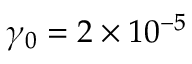Convert formula to latex. <formula><loc_0><loc_0><loc_500><loc_500>\gamma _ { 0 } = 2 \times 1 0 ^ { - 5 }</formula> 